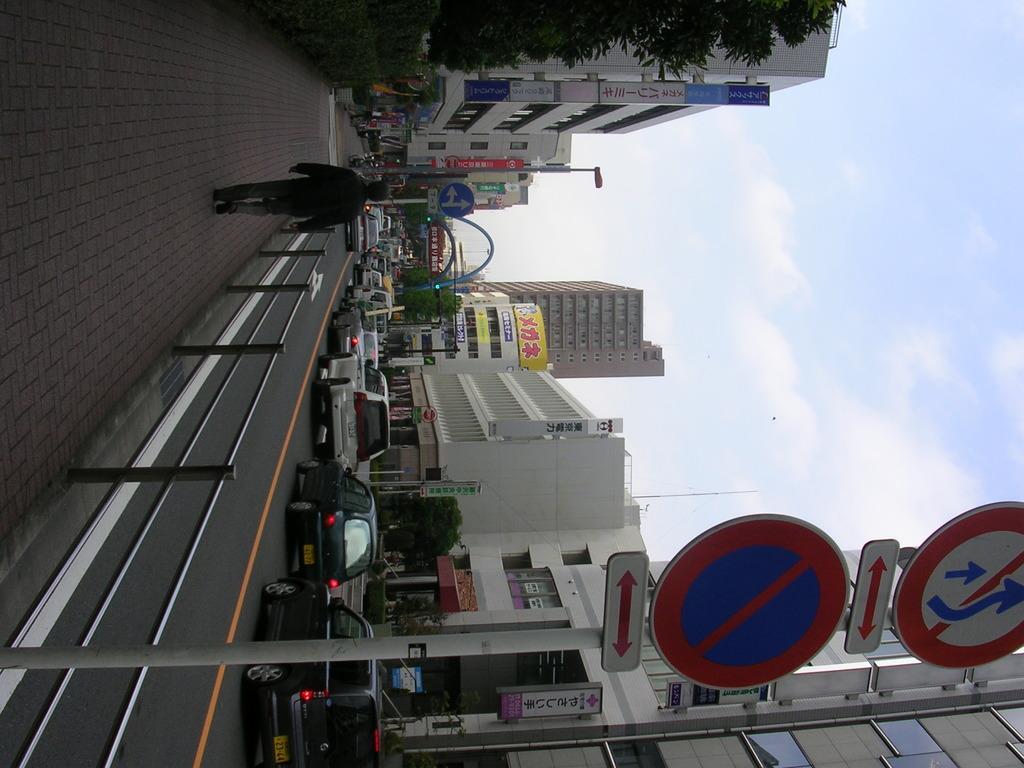Could you give a brief overview of what you see in this image? In this image there are some buildings, trees, vehicles and some persons are walking and also there are poles boards and on the left side there is a road, and on the right side there is sky. 